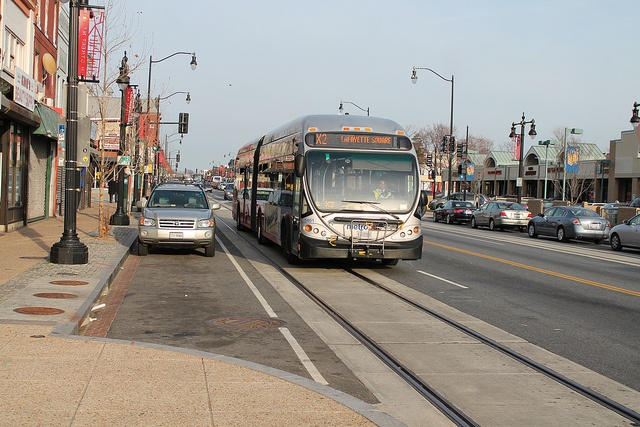Describe the objects in this image and their specific colors. I can see bus in salmon, black, gray, darkgray, and ivory tones, car in salmon, darkgray, black, gray, and ivory tones, car in salmon, black, gray, darkgray, and lightgray tones, car in salmon, gray, black, and ivory tones, and car in salmon, gray, black, and darkgray tones in this image. 